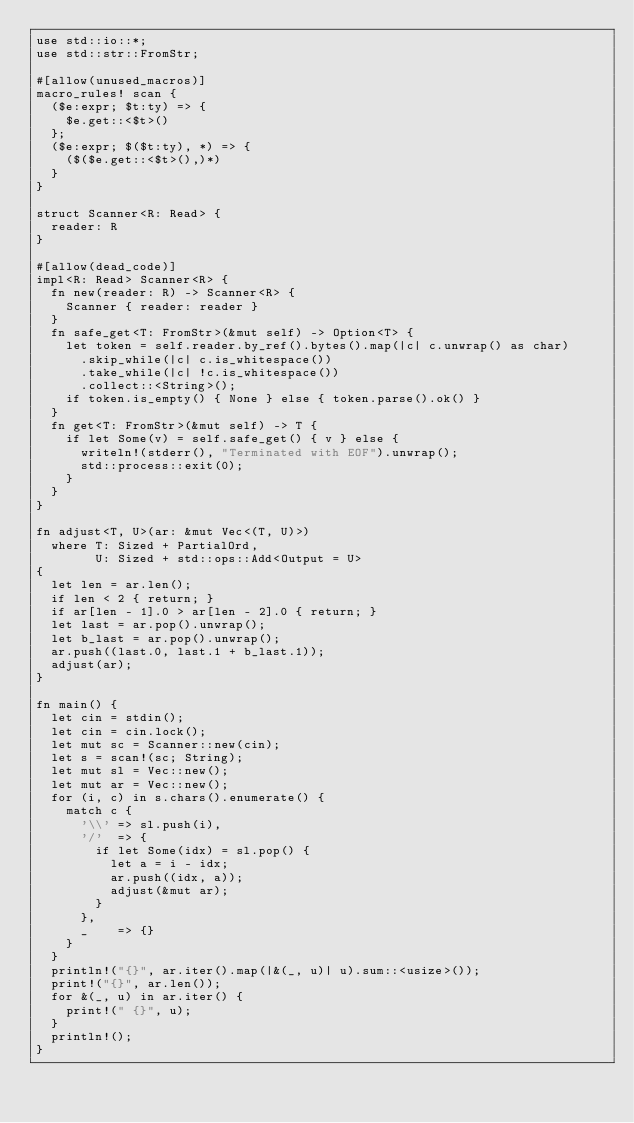Convert code to text. <code><loc_0><loc_0><loc_500><loc_500><_Rust_>use std::io::*;
use std::str::FromStr;

#[allow(unused_macros)]
macro_rules! scan {
  ($e:expr; $t:ty) => {
    $e.get::<$t>()
  };
  ($e:expr; $($t:ty), *) => {
    ($($e.get::<$t>(),)*)
  }
}

struct Scanner<R: Read> {
  reader: R
}

#[allow(dead_code)]
impl<R: Read> Scanner<R> {
  fn new(reader: R) -> Scanner<R> {
    Scanner { reader: reader }
  }
  fn safe_get<T: FromStr>(&mut self) -> Option<T> {
    let token = self.reader.by_ref().bytes().map(|c| c.unwrap() as char)
      .skip_while(|c| c.is_whitespace())
      .take_while(|c| !c.is_whitespace())
      .collect::<String>();
    if token.is_empty() { None } else { token.parse().ok() }
  }
  fn get<T: FromStr>(&mut self) -> T {
    if let Some(v) = self.safe_get() { v } else {
      writeln!(stderr(), "Terminated with EOF").unwrap();
      std::process::exit(0);
    }
  }
}

fn adjust<T, U>(ar: &mut Vec<(T, U)>)
  where T: Sized + PartialOrd,
        U: Sized + std::ops::Add<Output = U>
{
  let len = ar.len();
  if len < 2 { return; }
  if ar[len - 1].0 > ar[len - 2].0 { return; }
  let last = ar.pop().unwrap();
  let b_last = ar.pop().unwrap();
  ar.push((last.0, last.1 + b_last.1));
  adjust(ar);
}

fn main() {
  let cin = stdin();
  let cin = cin.lock();
  let mut sc = Scanner::new(cin);
  let s = scan!(sc; String);
  let mut sl = Vec::new();
  let mut ar = Vec::new();
  for (i, c) in s.chars().enumerate() {
    match c {
      '\\' => sl.push(i),
      '/'  => {
        if let Some(idx) = sl.pop() {
          let a = i - idx;
          ar.push((idx, a));
          adjust(&mut ar);
        }
      },
      _    => {}
    }
  }
  println!("{}", ar.iter().map(|&(_, u)| u).sum::<usize>());
  print!("{}", ar.len());
  for &(_, u) in ar.iter() {
    print!(" {}", u);
  }
  println!();
}

</code> 